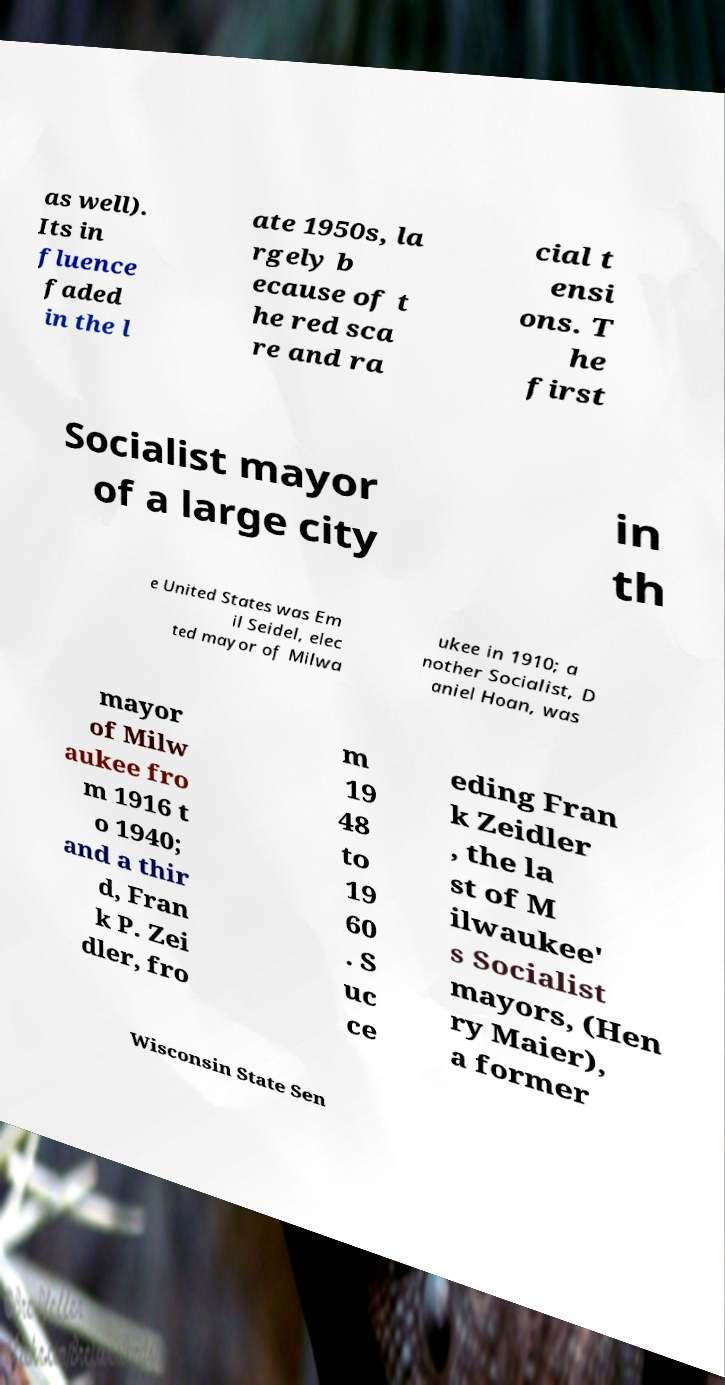Can you read and provide the text displayed in the image?This photo seems to have some interesting text. Can you extract and type it out for me? as well). Its in fluence faded in the l ate 1950s, la rgely b ecause of t he red sca re and ra cial t ensi ons. T he first Socialist mayor of a large city in th e United States was Em il Seidel, elec ted mayor of Milwa ukee in 1910; a nother Socialist, D aniel Hoan, was mayor of Milw aukee fro m 1916 t o 1940; and a thir d, Fran k P. Zei dler, fro m 19 48 to 19 60 . S uc ce eding Fran k Zeidler , the la st of M ilwaukee' s Socialist mayors, (Hen ry Maier), a former Wisconsin State Sen 